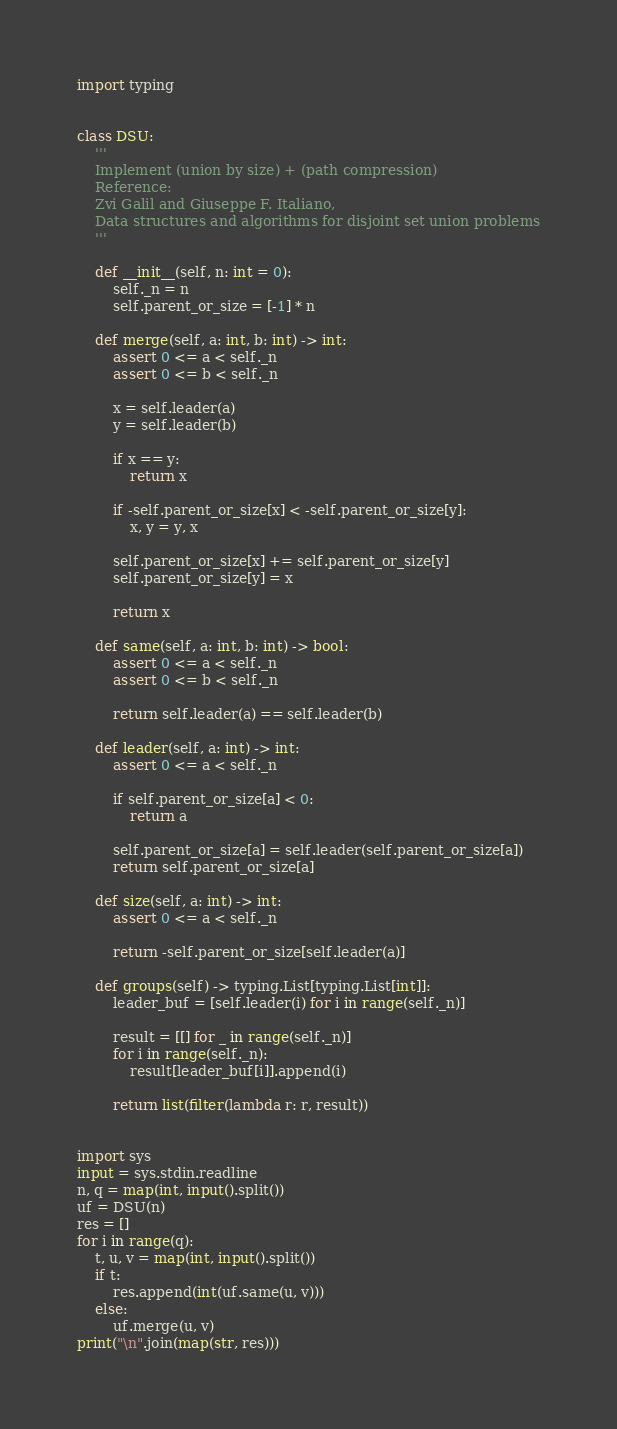Convert code to text. <code><loc_0><loc_0><loc_500><loc_500><_Python_>import typing


class DSU:
    '''
    Implement (union by size) + (path compression)
    Reference:
    Zvi Galil and Giuseppe F. Italiano,
    Data structures and algorithms for disjoint set union problems
    '''

    def __init__(self, n: int = 0):
        self._n = n
        self.parent_or_size = [-1] * n

    def merge(self, a: int, b: int) -> int:
        assert 0 <= a < self._n
        assert 0 <= b < self._n

        x = self.leader(a)
        y = self.leader(b)

        if x == y:
            return x

        if -self.parent_or_size[x] < -self.parent_or_size[y]:
            x, y = y, x

        self.parent_or_size[x] += self.parent_or_size[y]
        self.parent_or_size[y] = x

        return x

    def same(self, a: int, b: int) -> bool:
        assert 0 <= a < self._n
        assert 0 <= b < self._n

        return self.leader(a) == self.leader(b)

    def leader(self, a: int) -> int:
        assert 0 <= a < self._n

        if self.parent_or_size[a] < 0:
            return a

        self.parent_or_size[a] = self.leader(self.parent_or_size[a])
        return self.parent_or_size[a]

    def size(self, a: int) -> int:
        assert 0 <= a < self._n

        return -self.parent_or_size[self.leader(a)]

    def groups(self) -> typing.List[typing.List[int]]:
        leader_buf = [self.leader(i) for i in range(self._n)]

        result = [[] for _ in range(self._n)]
        for i in range(self._n):
            result[leader_buf[i]].append(i)

        return list(filter(lambda r: r, result))


import sys
input = sys.stdin.readline
n, q = map(int, input().split())
uf = DSU(n)
res = []
for i in range(q):
    t, u, v = map(int, input().split())
    if t:
        res.append(int(uf.same(u, v)))
    else:
        uf.merge(u, v)
print("\n".join(map(str, res)))
</code> 